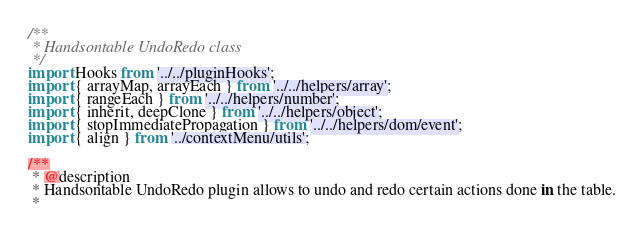Convert code to text. <code><loc_0><loc_0><loc_500><loc_500><_JavaScript_>/**
 * Handsontable UndoRedo class
 */
import Hooks from '../../pluginHooks';
import { arrayMap, arrayEach } from '../../helpers/array';
import { rangeEach } from '../../helpers/number';
import { inherit, deepClone } from '../../helpers/object';
import { stopImmediatePropagation } from '../../helpers/dom/event';
import { align } from '../contextMenu/utils';

/**
 * @description
 * Handsontable UndoRedo plugin allows to undo and redo certain actions done in the table.
 *</code> 